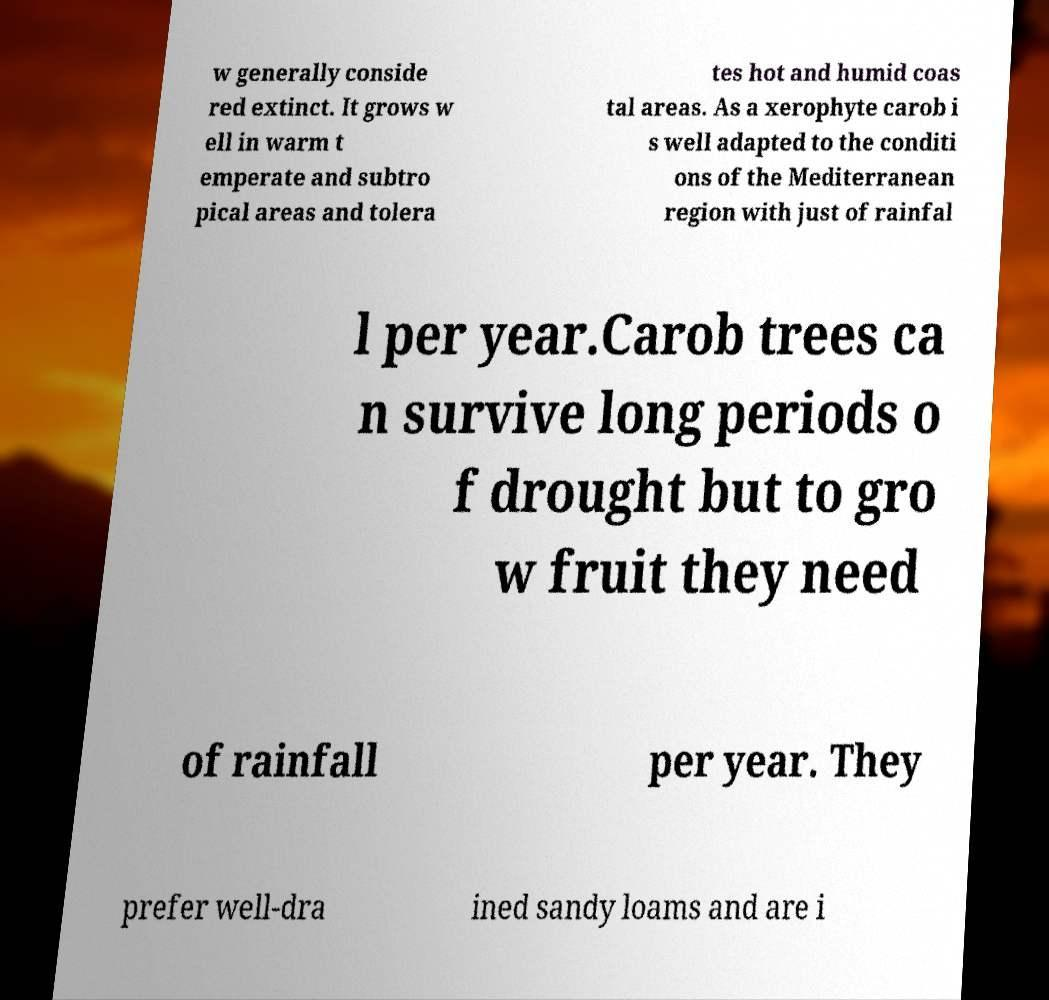Could you extract and type out the text from this image? w generally conside red extinct. It grows w ell in warm t emperate and subtro pical areas and tolera tes hot and humid coas tal areas. As a xerophyte carob i s well adapted to the conditi ons of the Mediterranean region with just of rainfal l per year.Carob trees ca n survive long periods o f drought but to gro w fruit they need of rainfall per year. They prefer well-dra ined sandy loams and are i 